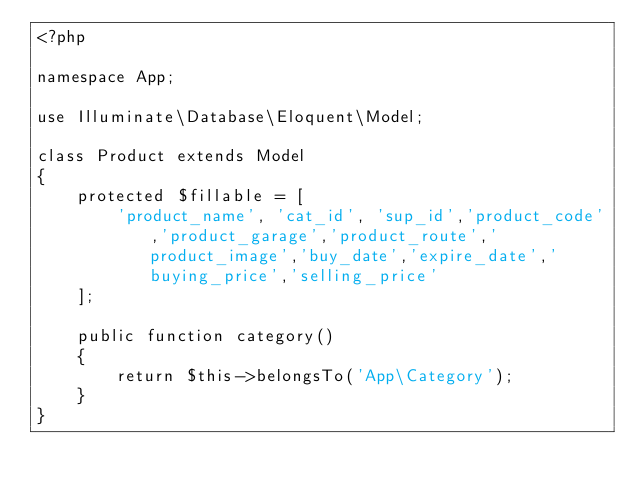<code> <loc_0><loc_0><loc_500><loc_500><_PHP_><?php

namespace App;

use Illuminate\Database\Eloquent\Model;

class Product extends Model
{
    protected $fillable = [
        'product_name', 'cat_id', 'sup_id','product_code','product_garage','product_route','product_image','buy_date','expire_date','buying_price','selling_price'
    ];

    public function category()
    {
        return $this->belongsTo('App\Category');
    }
}
</code> 